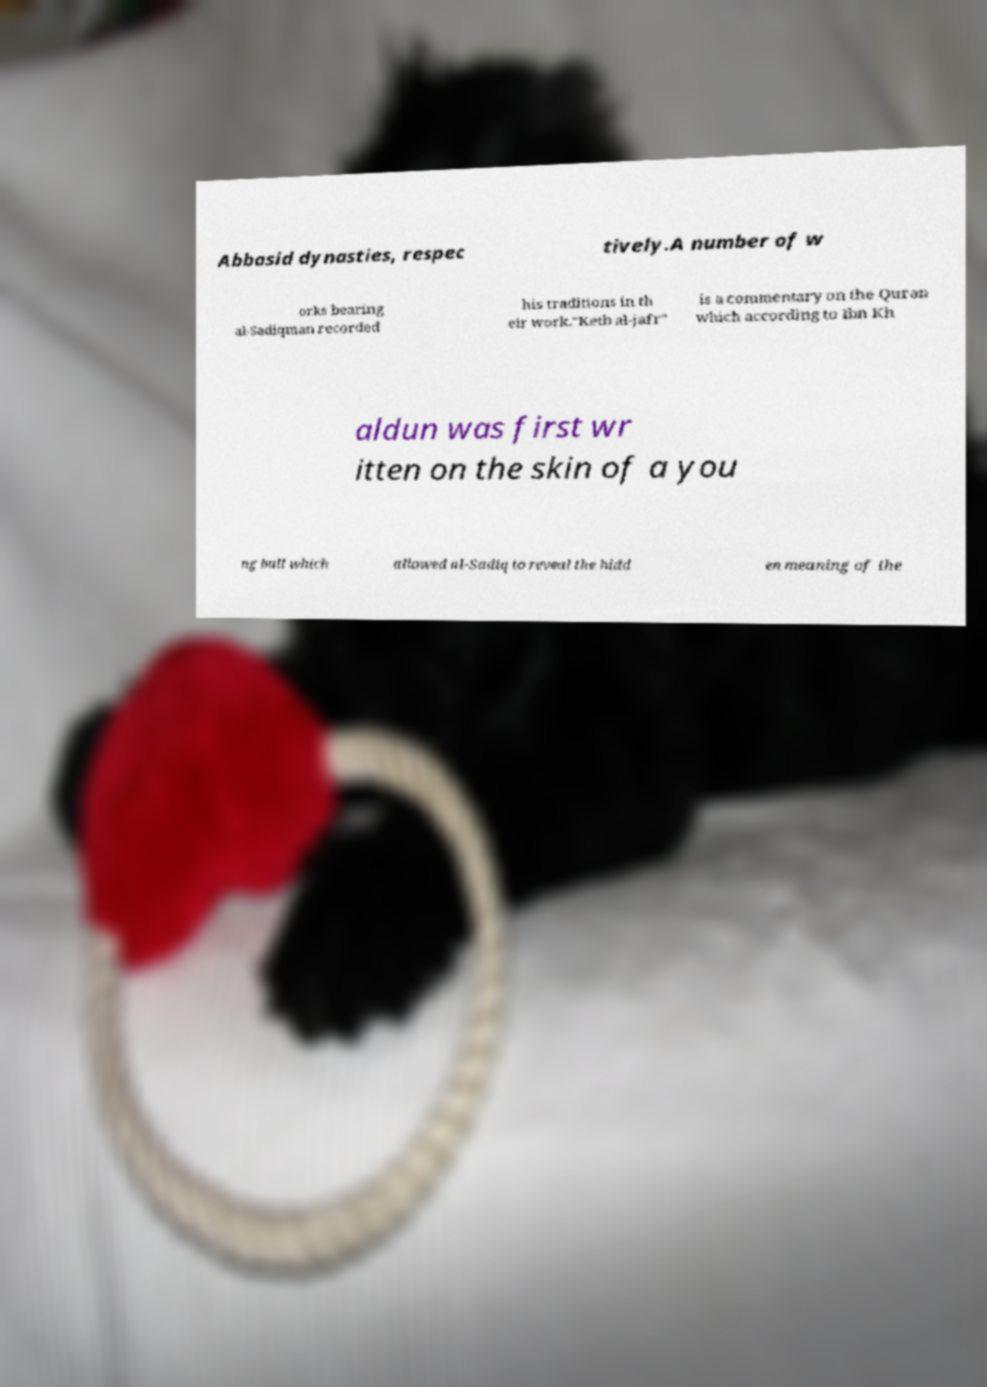There's text embedded in this image that I need extracted. Can you transcribe it verbatim? Abbasid dynasties, respec tively.A number of w orks bearing al-Sadiqman recorded his traditions in th eir work."Ketb al-jafr" is a commentary on the Quran which according to Ibn Kh aldun was first wr itten on the skin of a you ng bull which allowed al-Sadiq to reveal the hidd en meaning of the 